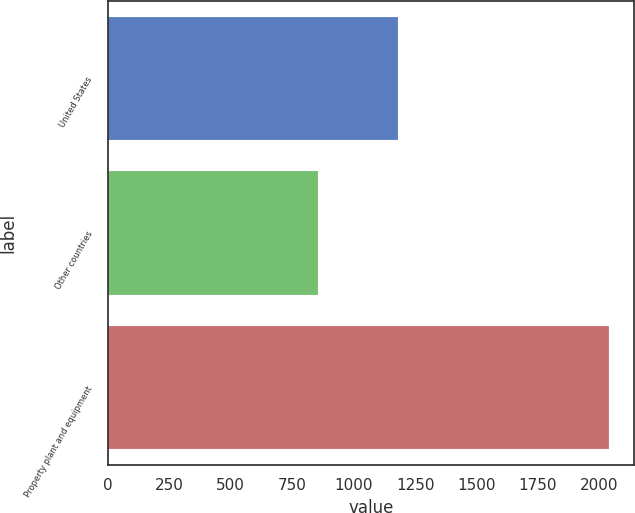Convert chart. <chart><loc_0><loc_0><loc_500><loc_500><bar_chart><fcel>United States<fcel>Other countries<fcel>Property plant and equipment<nl><fcel>1181.3<fcel>856.6<fcel>2037.9<nl></chart> 